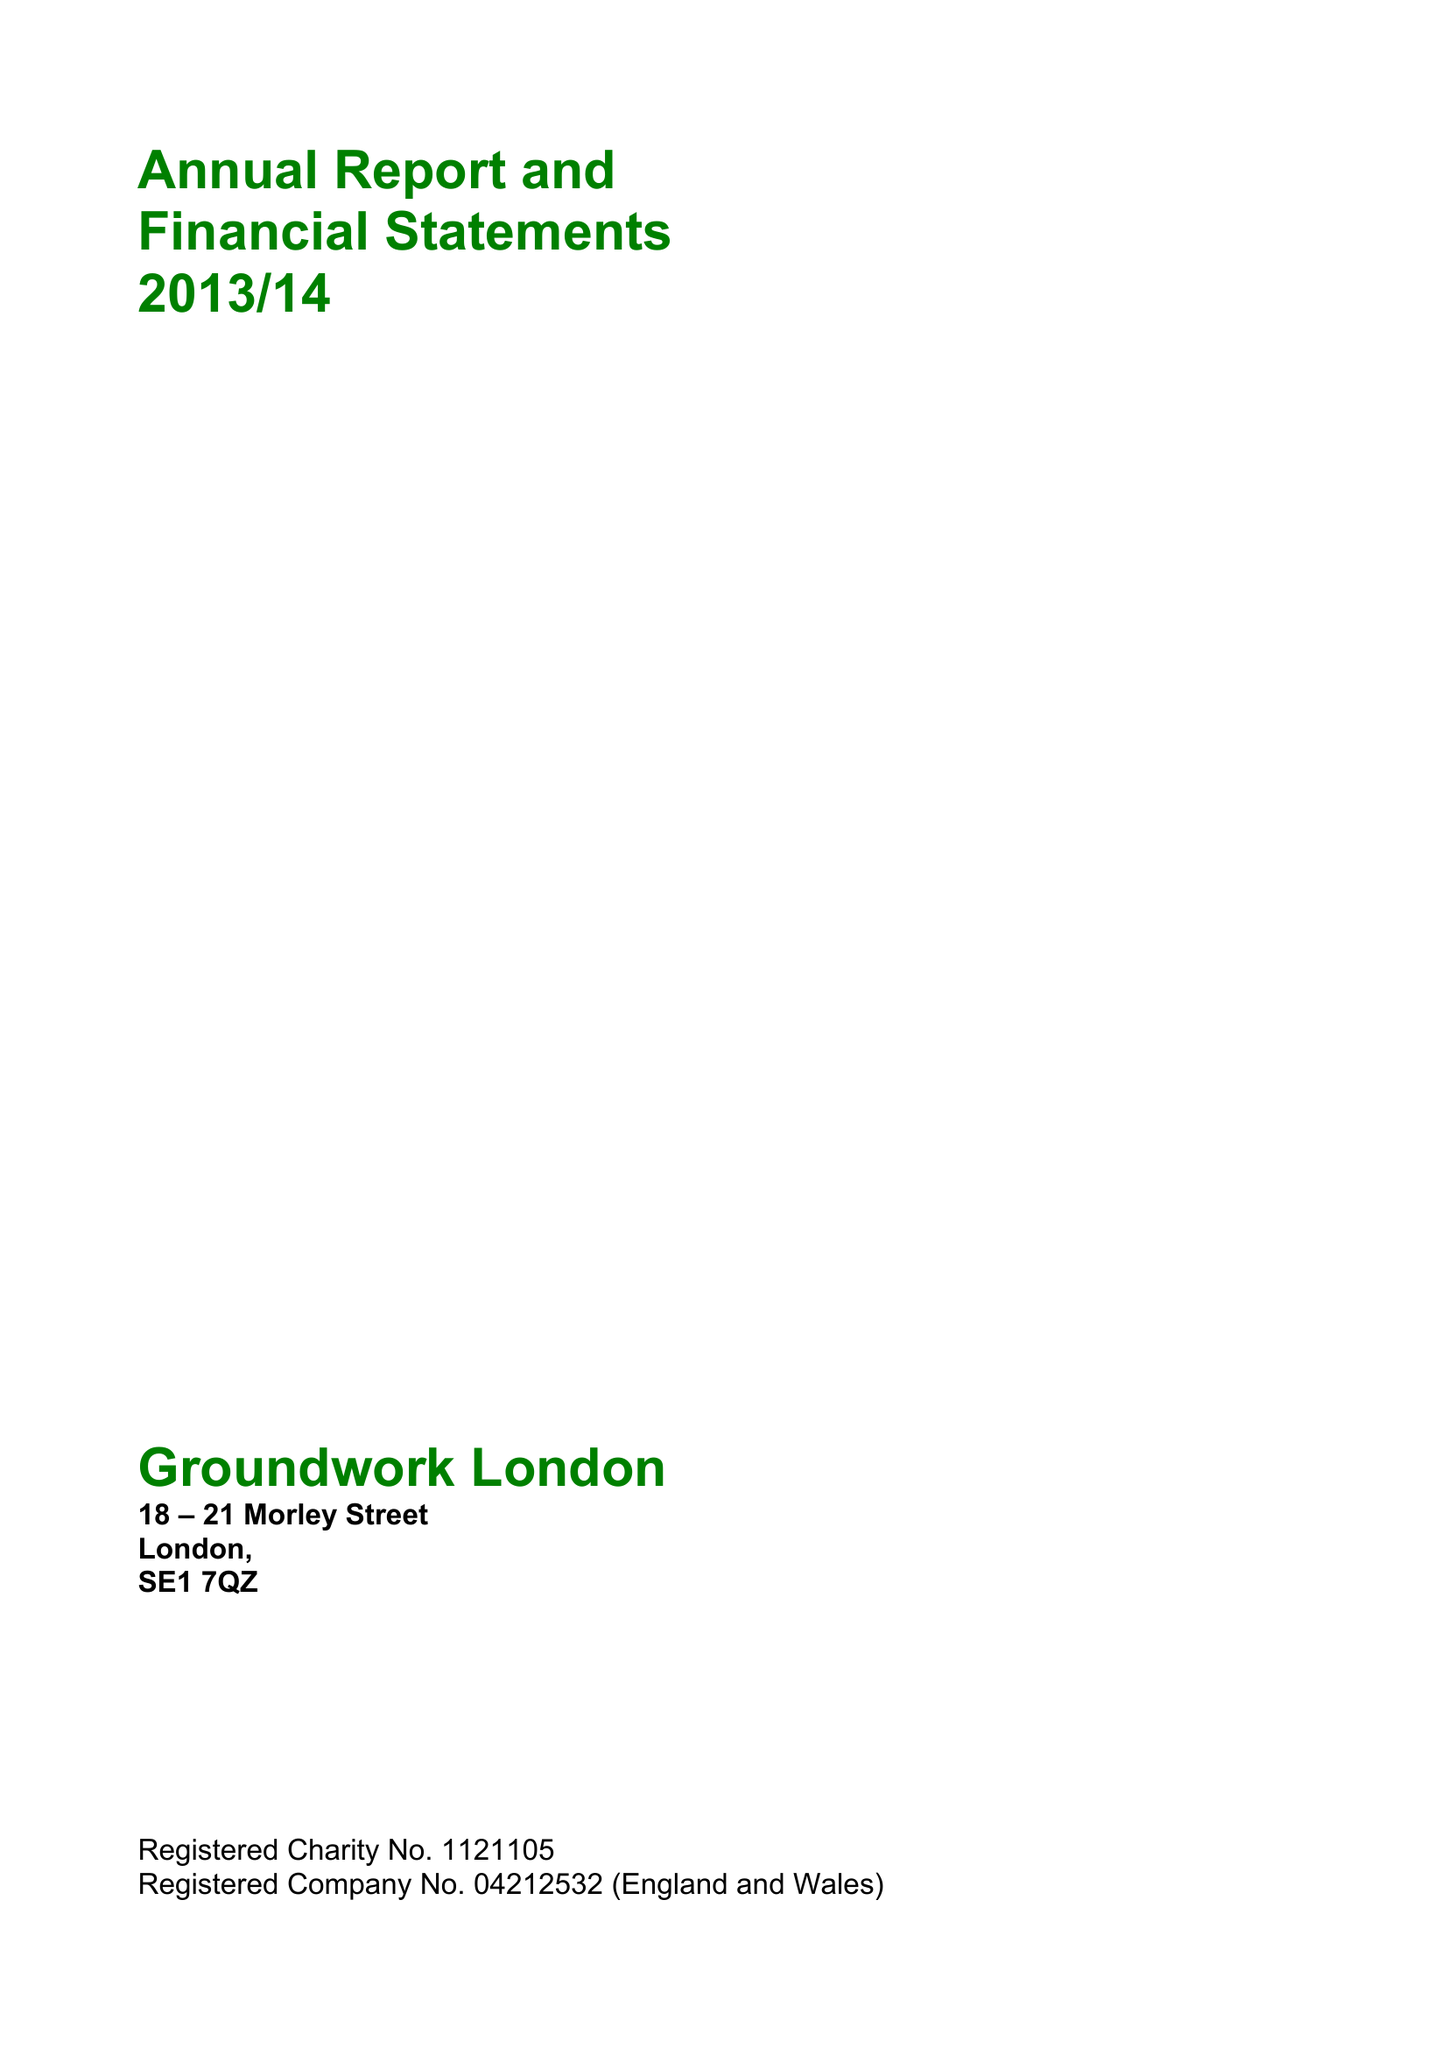What is the value for the address__postcode?
Answer the question using a single word or phrase. SE1 7QZ 